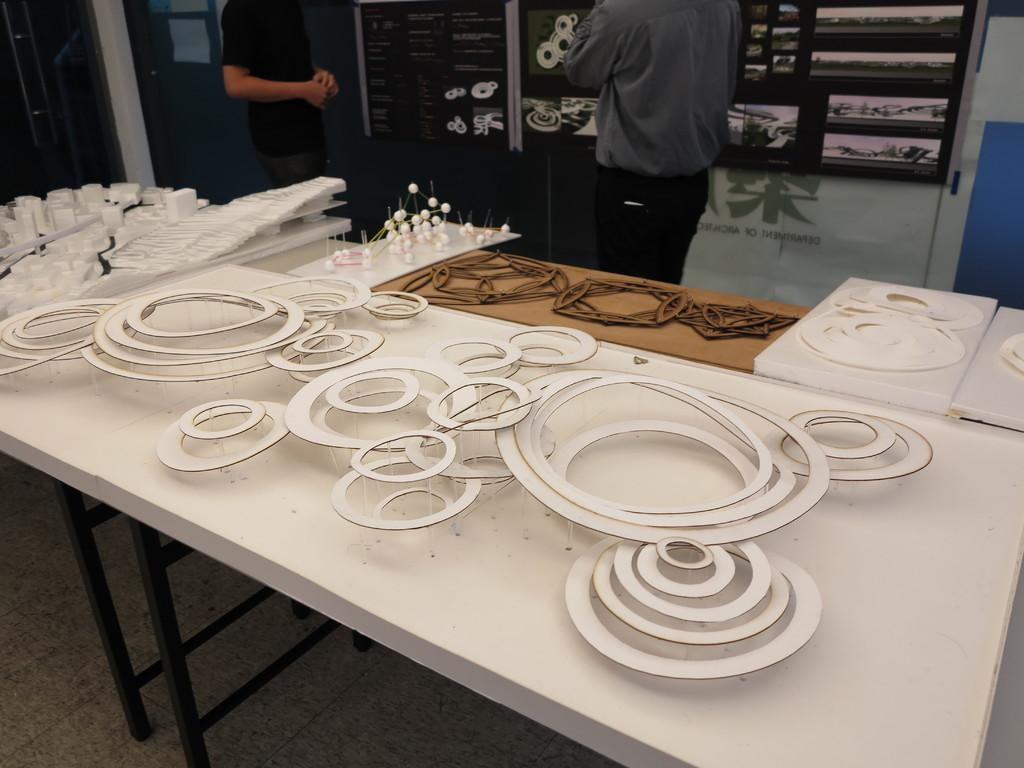Where was the image taken? The image was taken in a room. What furniture can be seen in the room? There are tables in the room. How many people are in the image? There are two persons near the table. What decorations are around the table? There are cardboard cuttings around the table. Can you see the family enjoying a day at the ocean in the image? No, the image does not show a family at the ocean. The image is taken in a room with tables and cardboard cuttings. 